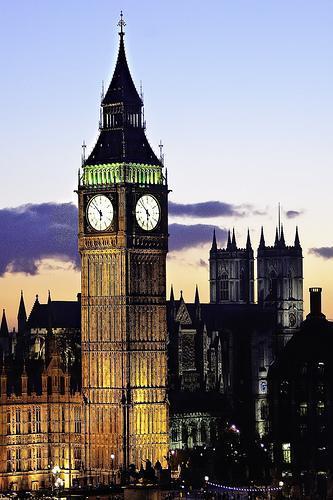How many clock faces are pictured?
Give a very brief answer. 2. 